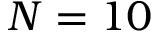Convert formula to latex. <formula><loc_0><loc_0><loc_500><loc_500>N = 1 0</formula> 